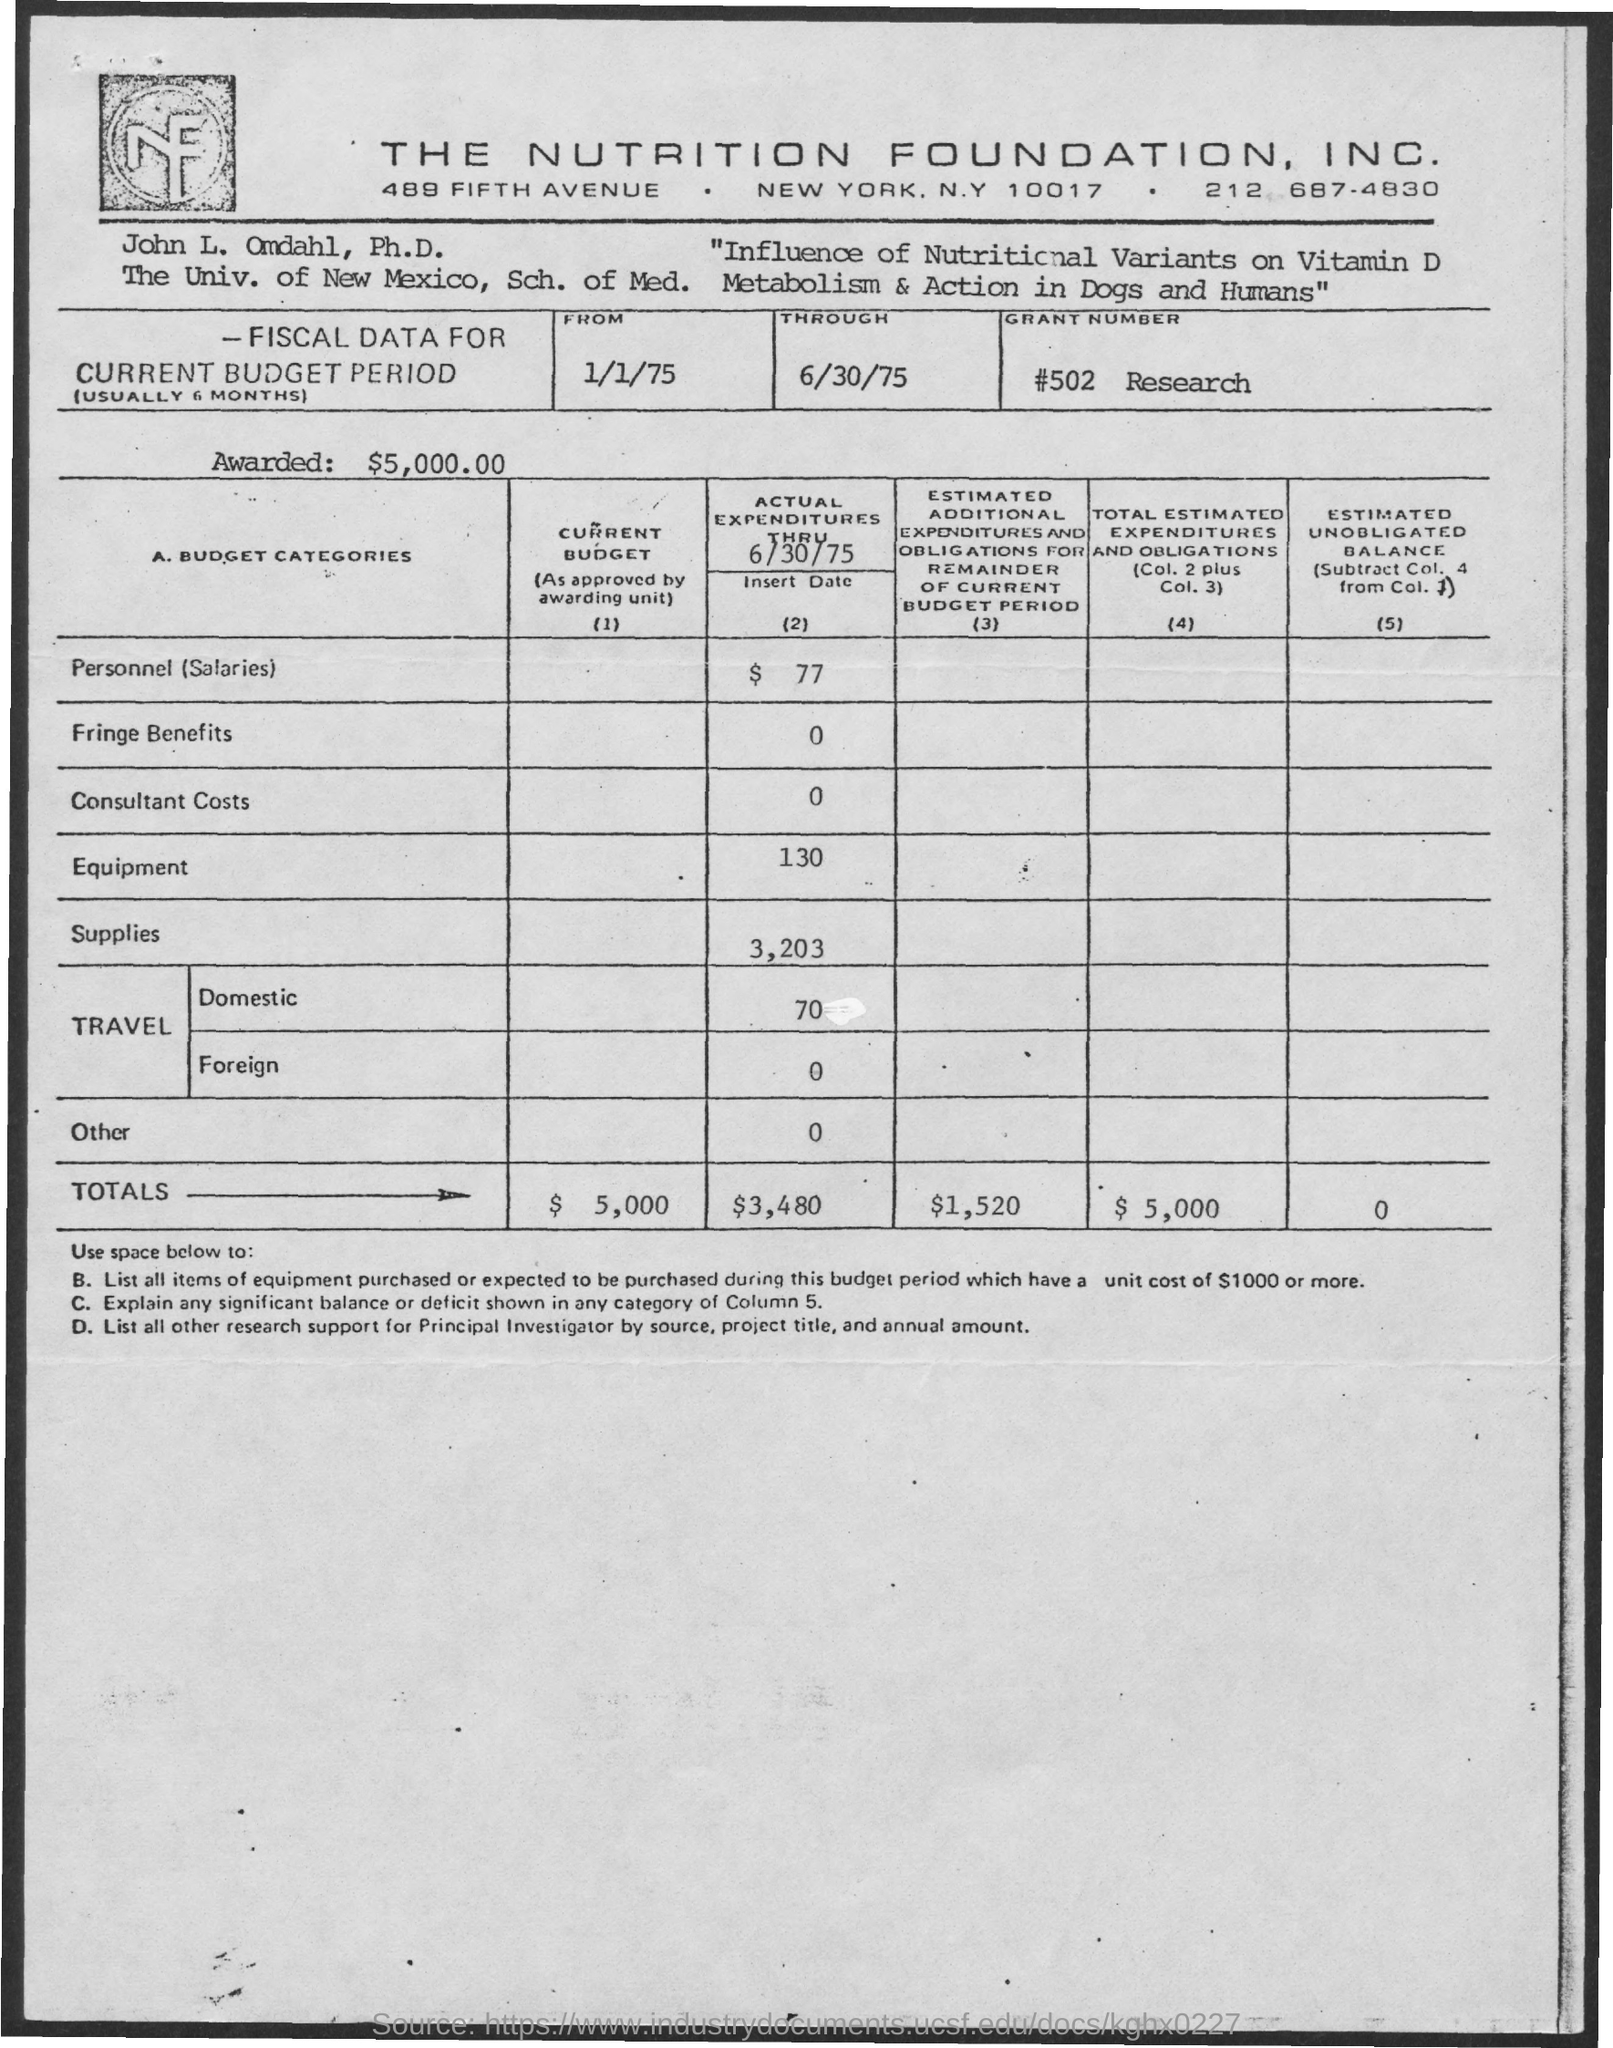Identify some key points in this picture. The current budget totals are 5,000. The Grant Number is #502 Research. In the given text, "What is the Actual Expenditures thru 6/30/75 for Fringe Benefits? 0..." is a question seeking information about the expenditures for fringe benefits during a specific time period. The actual expenditures through June 30, 1975 for consultant costs were $0. The actual expenditures up to June 30, 1975 for supplies were $3,203. 